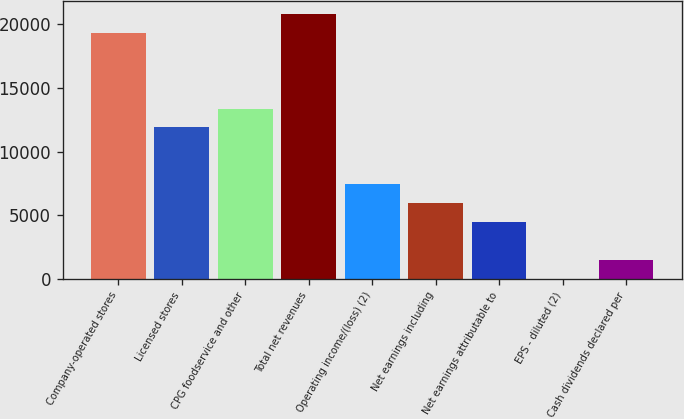<chart> <loc_0><loc_0><loc_500><loc_500><bar_chart><fcel>Company-operated stores<fcel>Licensed stores<fcel>CPG foodservice and other<fcel>Total net revenues<fcel>Operating income/(loss) (2)<fcel>Net earnings including<fcel>Net earnings attributable to<fcel>EPS - diluted (2)<fcel>Cash dividends declared per<nl><fcel>19326.8<fcel>11893.5<fcel>13380.1<fcel>20813.5<fcel>7433.41<fcel>5946.73<fcel>4460.05<fcel>0.01<fcel>1486.69<nl></chart> 